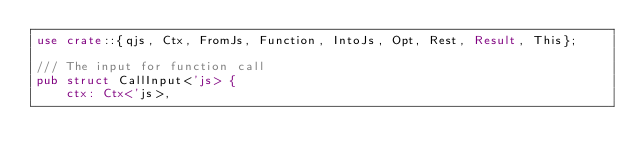Convert code to text. <code><loc_0><loc_0><loc_500><loc_500><_Rust_>use crate::{qjs, Ctx, FromJs, Function, IntoJs, Opt, Rest, Result, This};

/// The input for function call
pub struct CallInput<'js> {
    ctx: Ctx<'js>,</code> 